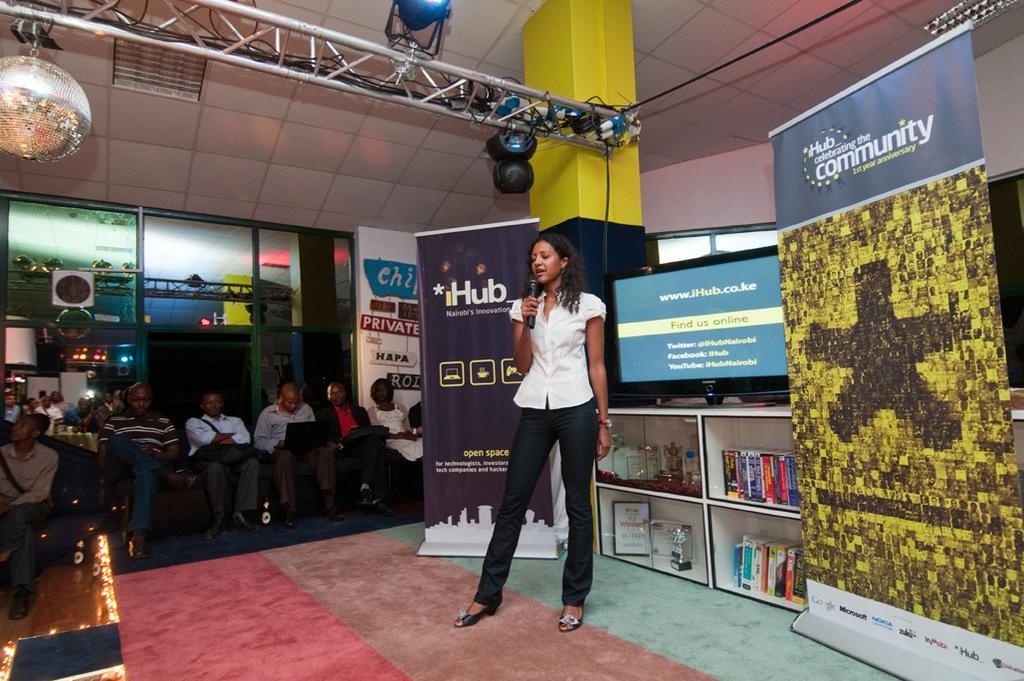Could you give a brief overview of what you see in this image? In this image we can see a lady standing on a stage and holding a microphone, behind her there is a cupboard which contains some books, other objects and there is a television on it, on its sides there are posters with text, in the background there is a group of people sitting and a few among them are holding objects, there are lights to the roof. 